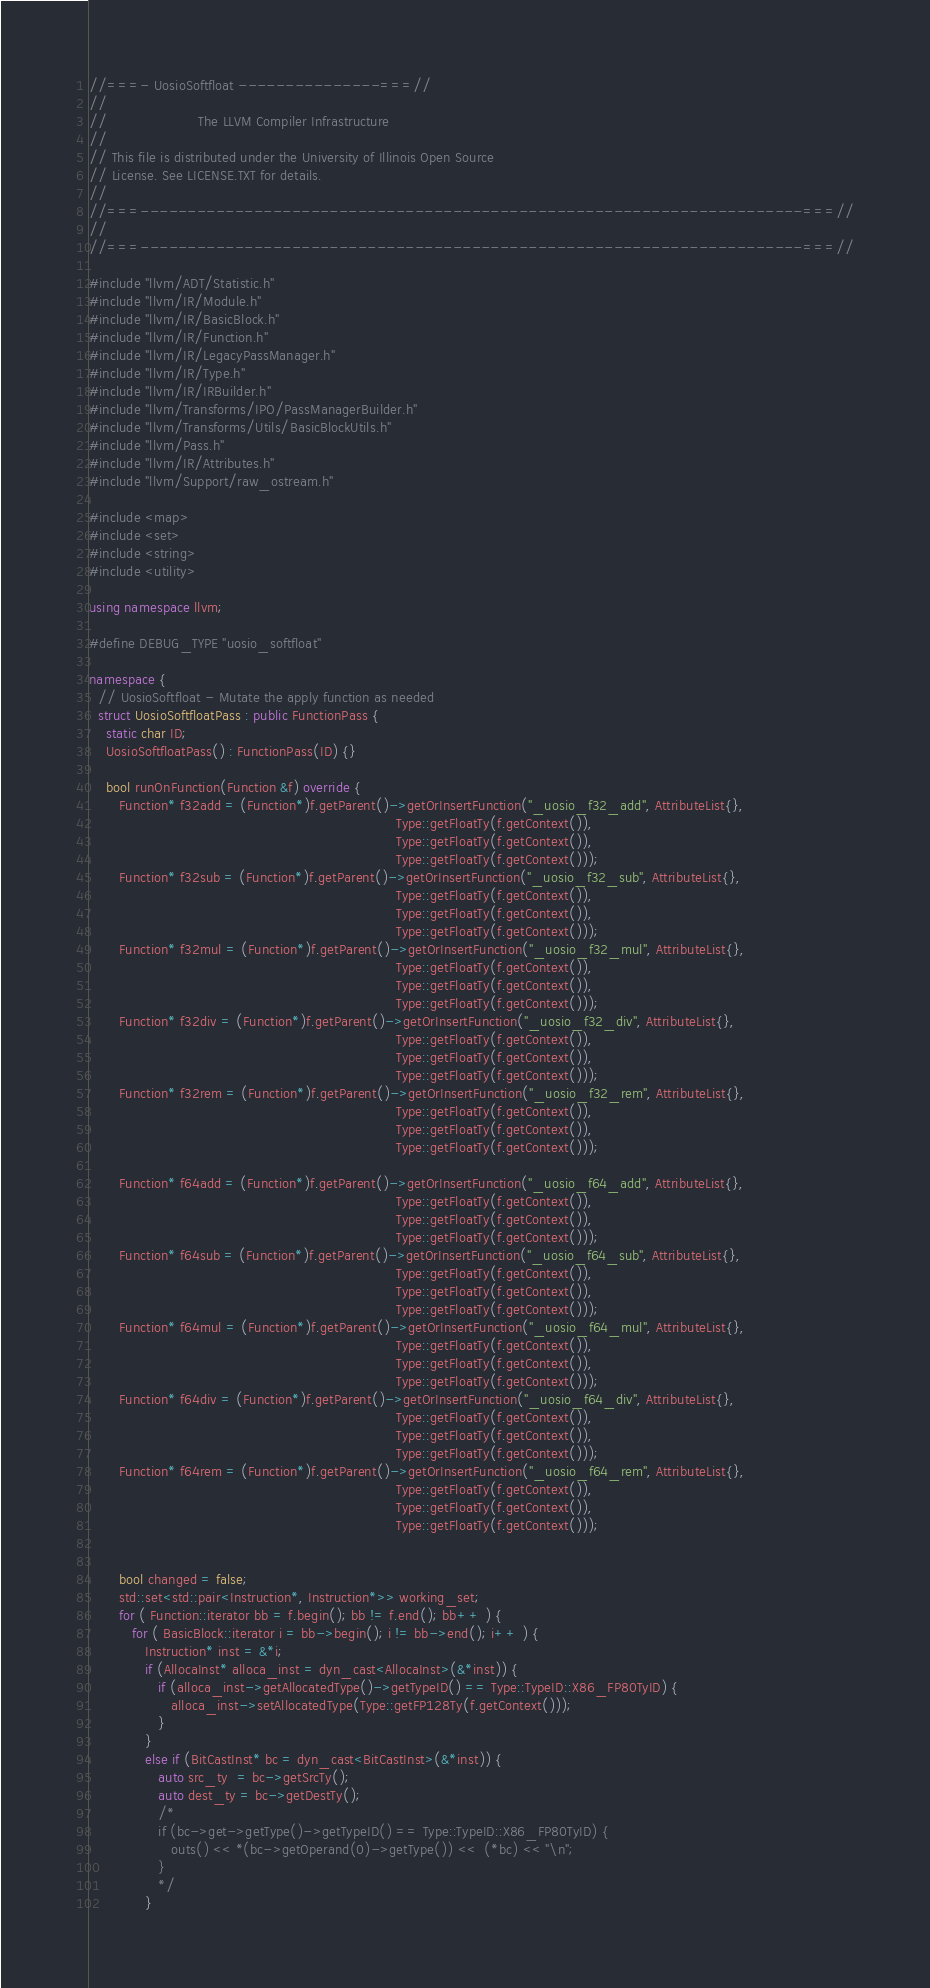Convert code to text. <code><loc_0><loc_0><loc_500><loc_500><_C++_>//===- UosioSoftfloat ---------------===//
//
//                     The LLVM Compiler Infrastructure
//
// This file is distributed under the University of Illinois Open Source
// License. See LICENSE.TXT for details.
//
//===----------------------------------------------------------------------===//
//
//===----------------------------------------------------------------------===//

#include "llvm/ADT/Statistic.h"
#include "llvm/IR/Module.h"
#include "llvm/IR/BasicBlock.h"
#include "llvm/IR/Function.h"
#include "llvm/IR/LegacyPassManager.h"
#include "llvm/IR/Type.h"
#include "llvm/IR/IRBuilder.h"
#include "llvm/Transforms/IPO/PassManagerBuilder.h"
#include "llvm/Transforms/Utils/BasicBlockUtils.h"
#include "llvm/Pass.h"
#include "llvm/IR/Attributes.h"
#include "llvm/Support/raw_ostream.h"

#include <map>
#include <set>
#include <string>
#include <utility>

using namespace llvm;

#define DEBUG_TYPE "uosio_softfloat"

namespace {
  // UosioSoftfloat - Mutate the apply function as needed 
  struct UosioSoftfloatPass : public FunctionPass {
    static char ID; 
    UosioSoftfloatPass() : FunctionPass(ID) {}
  
    bool runOnFunction(Function &f) override {
       Function* f32add = (Function*)f.getParent()->getOrInsertFunction("_uosio_f32_add", AttributeList{},
                                                                       Type::getFloatTy(f.getContext()),
                                                                       Type::getFloatTy(f.getContext()),
                                                                       Type::getFloatTy(f.getContext()));
       Function* f32sub = (Function*)f.getParent()->getOrInsertFunction("_uosio_f32_sub", AttributeList{},
                                                                       Type::getFloatTy(f.getContext()),
                                                                       Type::getFloatTy(f.getContext()),
                                                                       Type::getFloatTy(f.getContext()));
       Function* f32mul = (Function*)f.getParent()->getOrInsertFunction("_uosio_f32_mul", AttributeList{},
                                                                       Type::getFloatTy(f.getContext()),
                                                                       Type::getFloatTy(f.getContext()),
                                                                       Type::getFloatTy(f.getContext()));
       Function* f32div = (Function*)f.getParent()->getOrInsertFunction("_uosio_f32_div", AttributeList{},
                                                                       Type::getFloatTy(f.getContext()),
                                                                       Type::getFloatTy(f.getContext()),
                                                                       Type::getFloatTy(f.getContext()));
       Function* f32rem = (Function*)f.getParent()->getOrInsertFunction("_uosio_f32_rem", AttributeList{},
                                                                       Type::getFloatTy(f.getContext()),
                                                                       Type::getFloatTy(f.getContext()),
                                                                       Type::getFloatTy(f.getContext()));

       Function* f64add = (Function*)f.getParent()->getOrInsertFunction("_uosio_f64_add", AttributeList{},
                                                                       Type::getFloatTy(f.getContext()),
                                                                       Type::getFloatTy(f.getContext()),
                                                                       Type::getFloatTy(f.getContext()));
       Function* f64sub = (Function*)f.getParent()->getOrInsertFunction("_uosio_f64_sub", AttributeList{},
                                                                       Type::getFloatTy(f.getContext()),
                                                                       Type::getFloatTy(f.getContext()),
                                                                       Type::getFloatTy(f.getContext()));
       Function* f64mul = (Function*)f.getParent()->getOrInsertFunction("_uosio_f64_mul", AttributeList{},
                                                                       Type::getFloatTy(f.getContext()),
                                                                       Type::getFloatTy(f.getContext()),
                                                                       Type::getFloatTy(f.getContext()));
       Function* f64div = (Function*)f.getParent()->getOrInsertFunction("_uosio_f64_div", AttributeList{},
                                                                       Type::getFloatTy(f.getContext()),
                                                                       Type::getFloatTy(f.getContext()),
                                                                       Type::getFloatTy(f.getContext()));
       Function* f64rem = (Function*)f.getParent()->getOrInsertFunction("_uosio_f64_rem", AttributeList{},
                                                                       Type::getFloatTy(f.getContext()),
                                                                       Type::getFloatTy(f.getContext()),
                                                                       Type::getFloatTy(f.getContext()));


       bool changed = false;
       std::set<std::pair<Instruction*, Instruction*>> working_set;
       for ( Function::iterator bb = f.begin(); bb != f.end(); bb++ ) {
          for ( BasicBlock::iterator i = bb->begin(); i != bb->end(); i++ ) {
             Instruction* inst = &*i;
             if (AllocaInst* alloca_inst = dyn_cast<AllocaInst>(&*inst)) {
                if (alloca_inst->getAllocatedType()->getTypeID() == Type::TypeID::X86_FP80TyID) {
                   alloca_inst->setAllocatedType(Type::getFP128Ty(f.getContext()));
                }
             }
             else if (BitCastInst* bc = dyn_cast<BitCastInst>(&*inst)) {
                auto src_ty  = bc->getSrcTy();
                auto dest_ty = bc->getDestTy();
                /*
                if (bc->get->getType()->getTypeID() == Type::TypeID::X86_FP80TyID) {
                   outs() << *(bc->getOperand(0)->getType()) <<  (*bc) << "\n";
                }
                */
             }</code> 